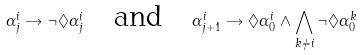Convert formula to latex. <formula><loc_0><loc_0><loc_500><loc_500>\alpha _ { j } ^ { i } \rightarrow \neg \Diamond \alpha ^ { i } _ { j } \quad \text {and} \quad \alpha _ { j + 1 } ^ { i } \rightarrow \Diamond \alpha ^ { i } _ { 0 } \wedge \bigwedge _ { k \not = i } \neg \Diamond \alpha ^ { k } _ { 0 }</formula> 